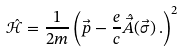<formula> <loc_0><loc_0><loc_500><loc_500>\hat { { \mathcal { H } } } = \frac { 1 } { 2 m } \left ( \vec { p } - \frac { e } { c } \hat { \vec { A } } ( \vec { \sigma } ) \, . \right ) ^ { 2 }</formula> 